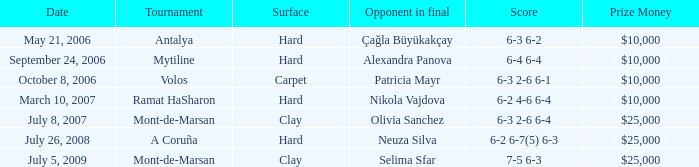Can you provide the score for the game held on september 24, 2006? 6-4 6-4. 